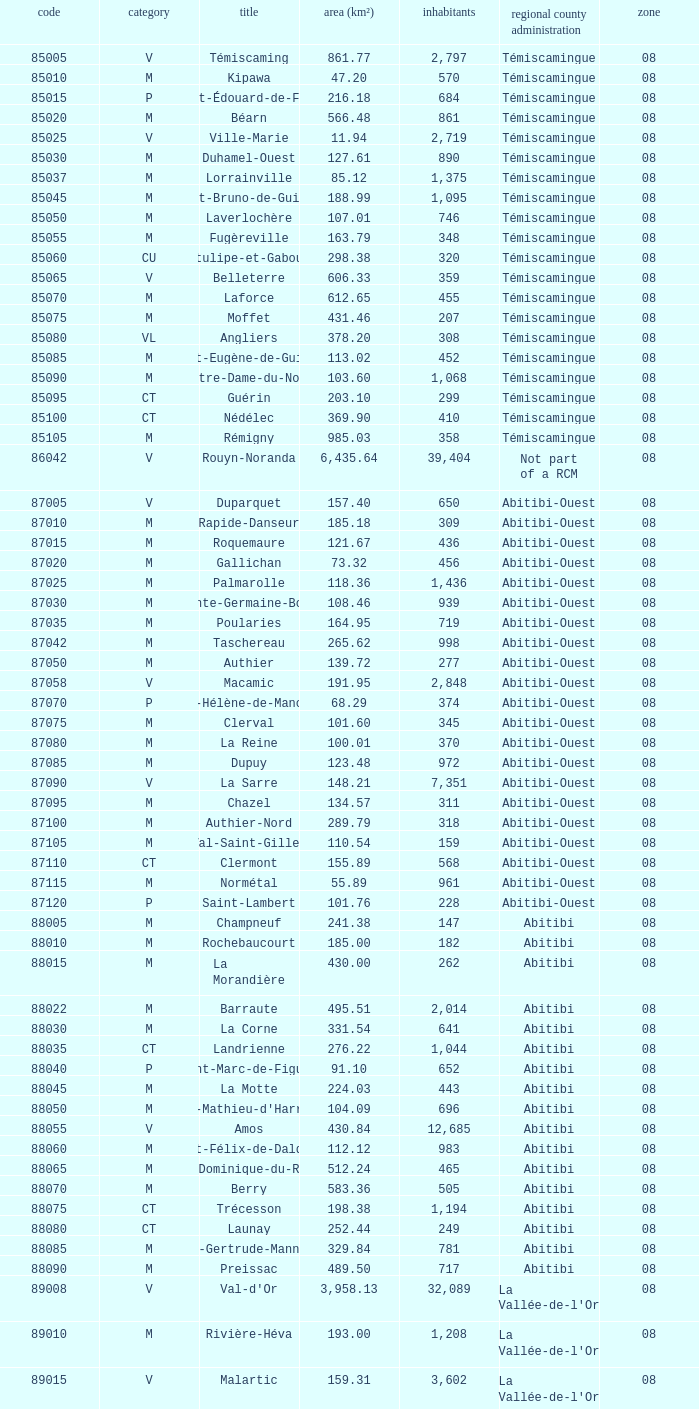What municipality has 719 people and is larger than 108.46 km2? Abitibi-Ouest. 